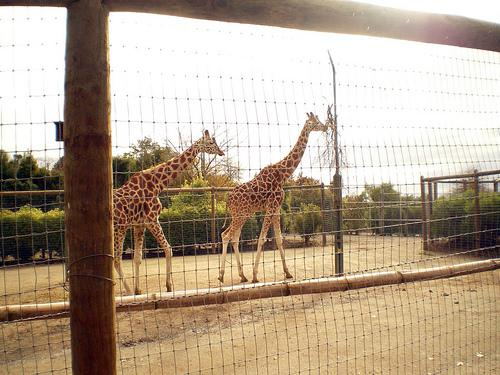Question: why do people go to the zoo?
Choices:
A. To see animals.
B. To amuse themselves.
C. To exploit animals.
D. To waste money.
Answer with the letter. Answer: A Question: who keeps a zoo?
Choices:
A. Researchers.
B. The wealthy.
C. Zookeeper.
D. Humans.
Answer with the letter. Answer: C Question: how many giraffes are in the picture?
Choices:
A. One.
B. Three.
C. Five.
D. Two.
Answer with the letter. Answer: D Question: what animals are in the picture?
Choices:
A. Zebras.
B. Giraffes.
C. Hippos.
D. Lions.
Answer with the letter. Answer: B 